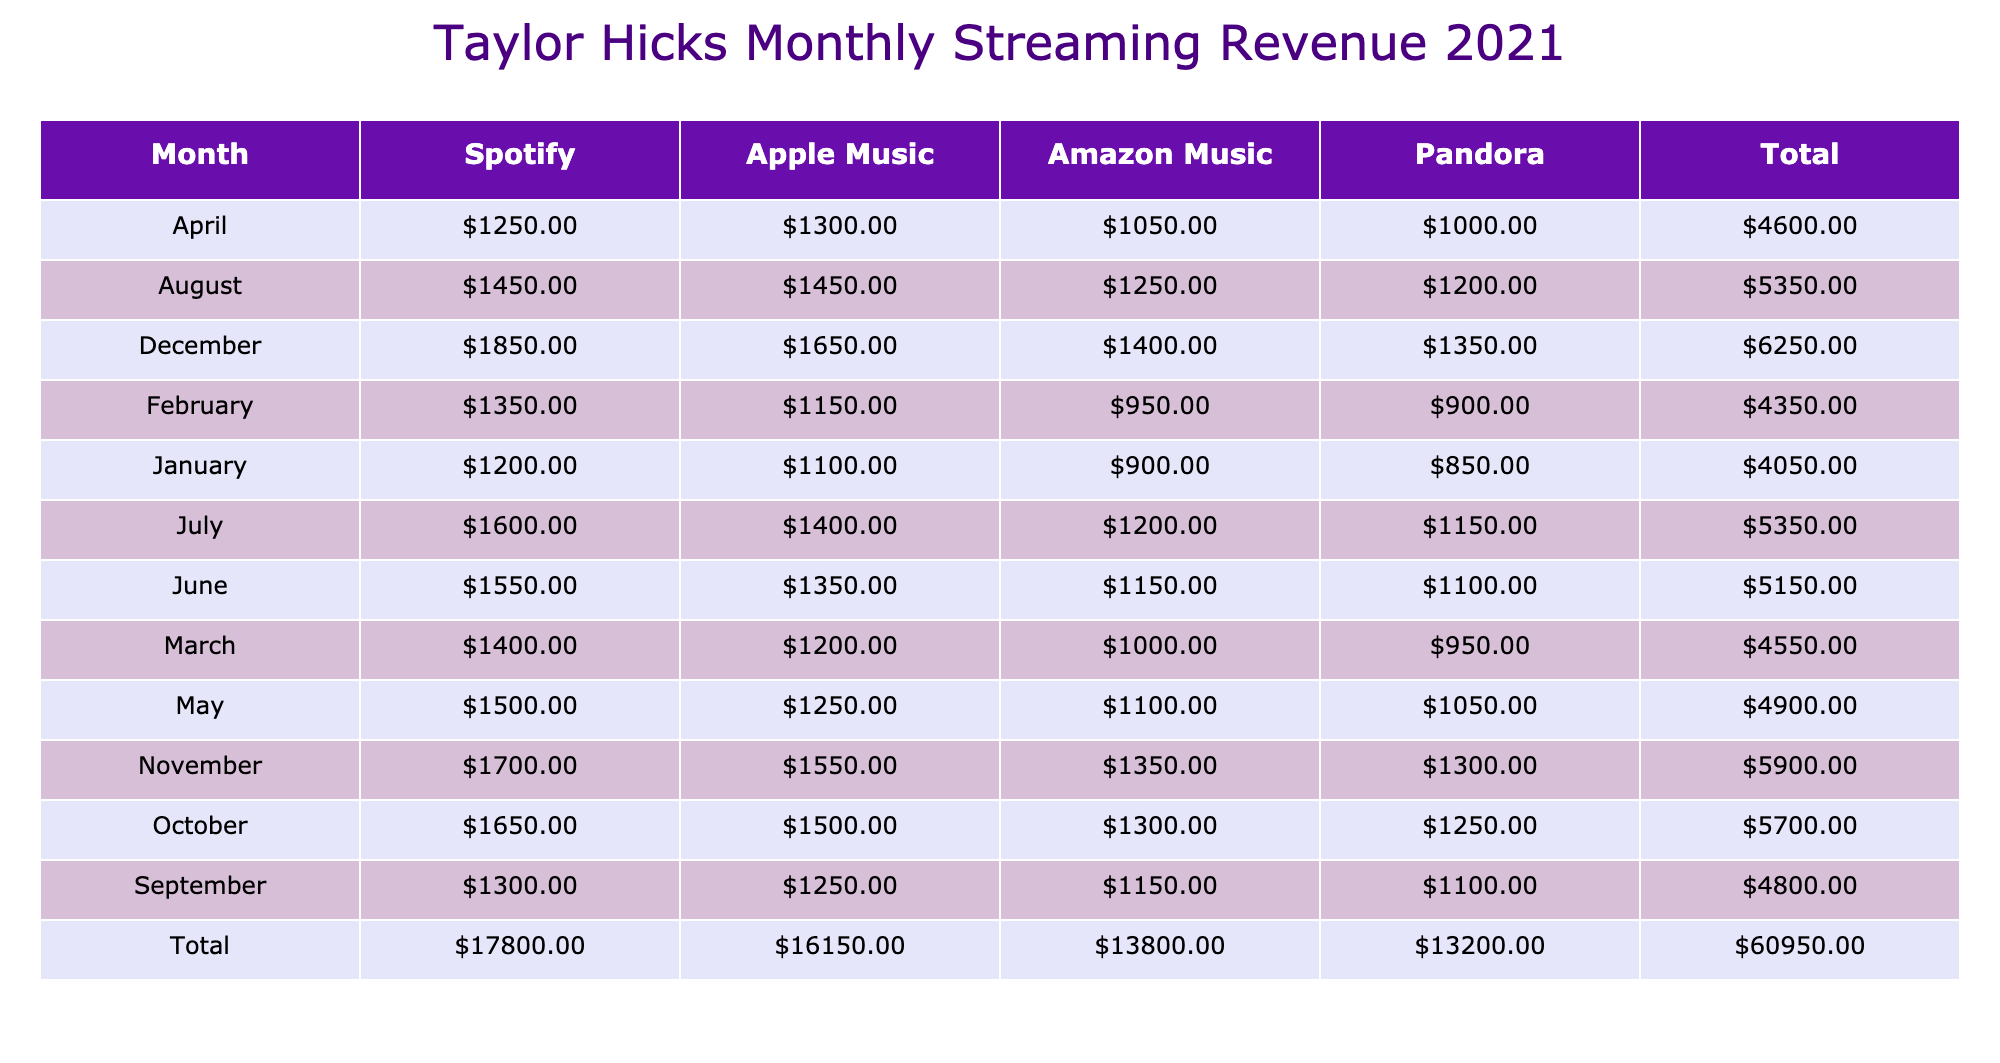What was Taylor Hicks’s highest streaming revenue in December 2021? The table shows the monthly streaming revenue for each platform in December. For Spotify, the revenue was 1850 USD, Apple Music was 1650 USD, Amazon Music was 1400 USD, and Pandora was 1350 USD. The highest value among these is 1850 USD from Spotify.
Answer: 1850 USD What was the total revenue for Taylor Hicks across all platforms in April 2021? In April, the revenue from each platform is as follows: Spotify 1250 USD, Apple Music 1300 USD, Amazon Music 1050 USD, and Pandora 1000 USD. Adding these values together gives 1250 + 1300 + 1050 + 1000 = 4600 USD.
Answer: 4600 USD Did Taylor Hicks earn more from Spotify than from Amazon Music in November 2021? In November, the revenue from Spotify is 1700 USD, while from Amazon Music it is 1350 USD. Since 1700 is greater than 1350, the answer is yes.
Answer: Yes What was the average monthly revenue for Taylor Hicks from Apple Music in 2021? The monthly revenues from Apple Music are: 1100, 1150, 1200, 1300, 1250, 1350, 1400, 1450, 1250, 1500, 1550, 1650. To find the average, sum these values: 1100 + 1150 + 1200 + 1300 + 1250 + 1350 + 1400 + 1450 + 1250 + 1500 + 1550 + 1650 = 16,800 USD. There are 12 months, so the average is 16,800 / 12 = 1400 USD.
Answer: 1400 USD What was the total revenue from Pandora for the entire year of 2021? The monthly revenues from Pandora are: 850, 900, 950, 1000, 1050, 1100, 1150, 1200, 1100, 1250, 1300, 1350. Summing these gives 850 + 900 + 950 + 1000 + 1050 + 1100 + 1150 + 1200 + 1100 + 1250 + 1300 + 1350 = 13,500 USD.
Answer: 13,500 USD 